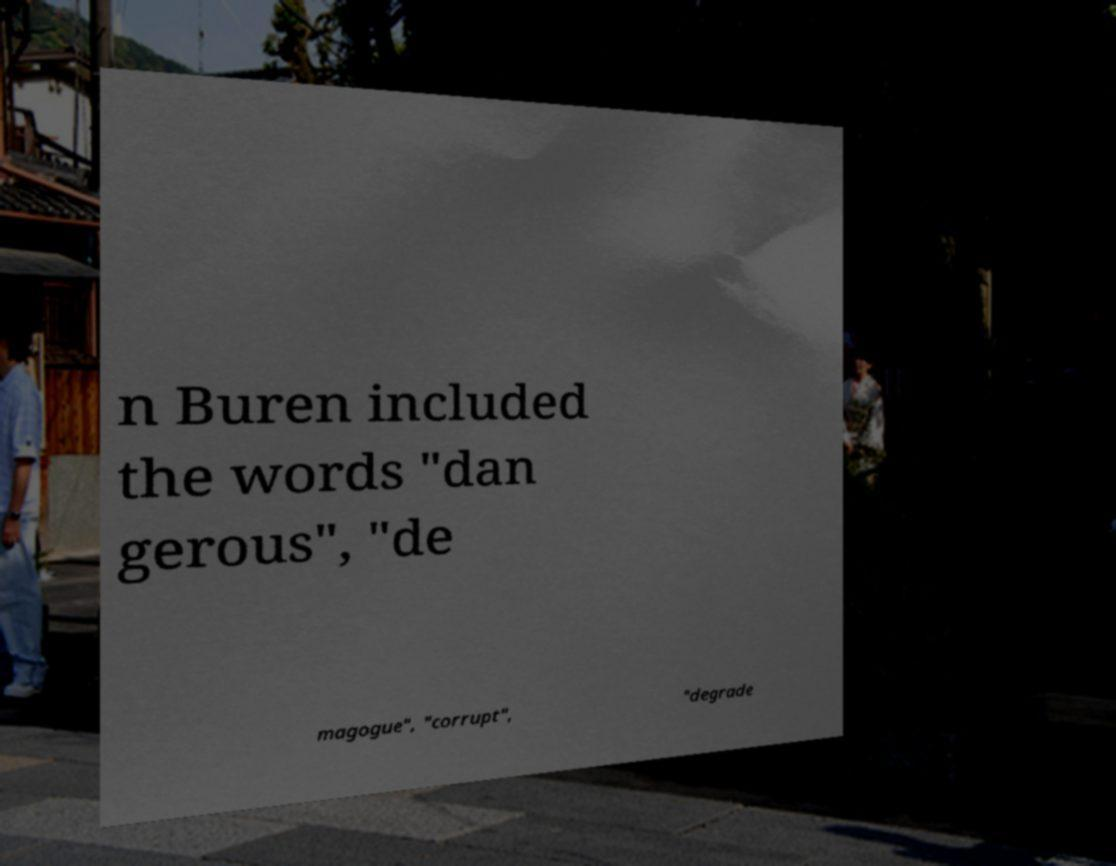Please identify and transcribe the text found in this image. n Buren included the words "dan gerous", "de magogue", "corrupt", "degrade 